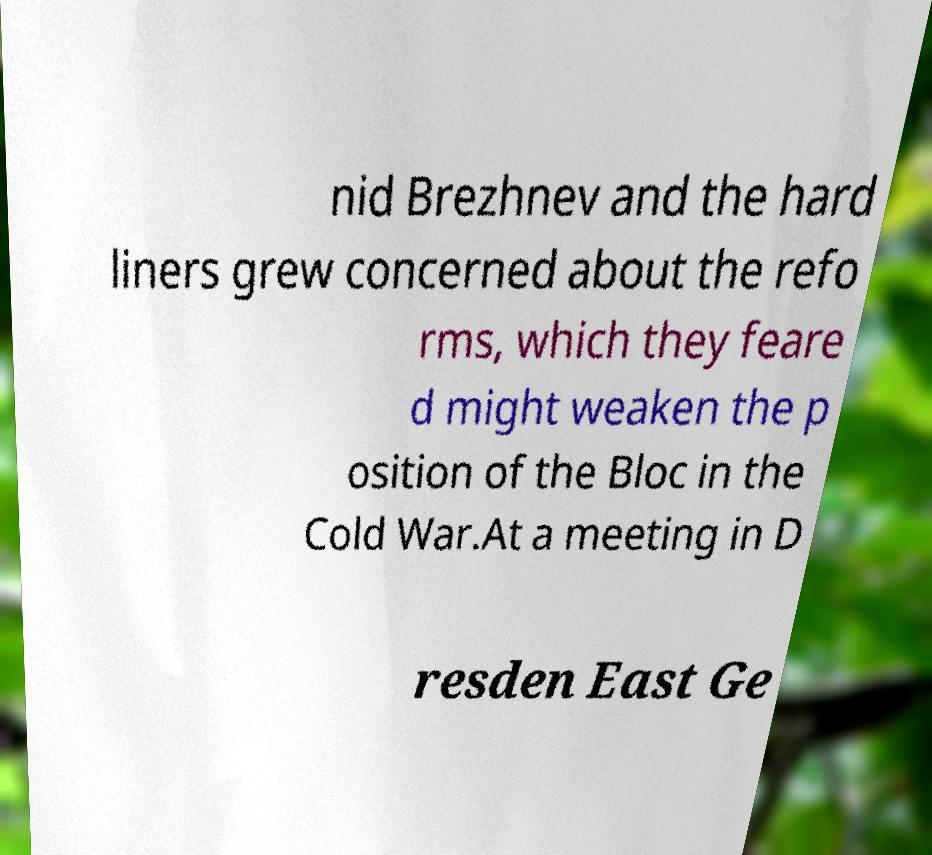What messages or text are displayed in this image? I need them in a readable, typed format. nid Brezhnev and the hard liners grew concerned about the refo rms, which they feare d might weaken the p osition of the Bloc in the Cold War.At a meeting in D resden East Ge 